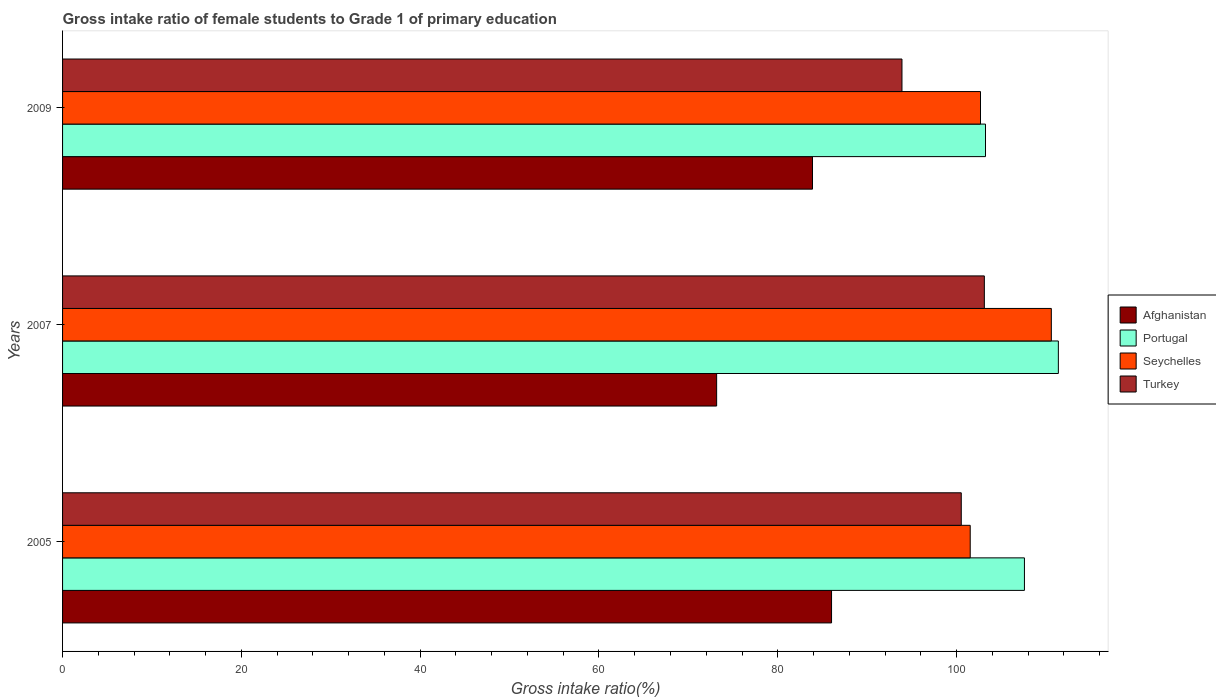Are the number of bars per tick equal to the number of legend labels?
Ensure brevity in your answer.  Yes. Are the number of bars on each tick of the Y-axis equal?
Your answer should be very brief. Yes. In how many cases, is the number of bars for a given year not equal to the number of legend labels?
Offer a very short reply. 0. What is the gross intake ratio in Afghanistan in 2009?
Your answer should be compact. 83.88. Across all years, what is the maximum gross intake ratio in Portugal?
Offer a terse response. 111.38. Across all years, what is the minimum gross intake ratio in Turkey?
Your response must be concise. 93.89. In which year was the gross intake ratio in Turkey maximum?
Keep it short and to the point. 2007. In which year was the gross intake ratio in Seychelles minimum?
Offer a terse response. 2005. What is the total gross intake ratio in Turkey in the graph?
Offer a very short reply. 297.52. What is the difference between the gross intake ratio in Turkey in 2007 and that in 2009?
Make the answer very short. 9.22. What is the difference between the gross intake ratio in Seychelles in 2009 and the gross intake ratio in Afghanistan in 2007?
Offer a terse response. 29.51. What is the average gross intake ratio in Seychelles per year?
Ensure brevity in your answer.  104.93. In the year 2007, what is the difference between the gross intake ratio in Portugal and gross intake ratio in Afghanistan?
Make the answer very short. 38.22. In how many years, is the gross intake ratio in Afghanistan greater than 80 %?
Provide a succinct answer. 2. What is the ratio of the gross intake ratio in Turkey in 2005 to that in 2007?
Provide a short and direct response. 0.97. Is the gross intake ratio in Portugal in 2005 less than that in 2009?
Keep it short and to the point. No. Is the difference between the gross intake ratio in Portugal in 2007 and 2009 greater than the difference between the gross intake ratio in Afghanistan in 2007 and 2009?
Offer a very short reply. Yes. What is the difference between the highest and the second highest gross intake ratio in Turkey?
Your answer should be compact. 2.58. What is the difference between the highest and the lowest gross intake ratio in Portugal?
Your response must be concise. 8.15. In how many years, is the gross intake ratio in Turkey greater than the average gross intake ratio in Turkey taken over all years?
Offer a terse response. 2. Is the sum of the gross intake ratio in Portugal in 2005 and 2009 greater than the maximum gross intake ratio in Seychelles across all years?
Keep it short and to the point. Yes. What does the 2nd bar from the top in 2009 represents?
Provide a short and direct response. Seychelles. What does the 2nd bar from the bottom in 2007 represents?
Your response must be concise. Portugal. Is it the case that in every year, the sum of the gross intake ratio in Afghanistan and gross intake ratio in Turkey is greater than the gross intake ratio in Seychelles?
Your answer should be compact. Yes. How many bars are there?
Offer a terse response. 12. What is the difference between two consecutive major ticks on the X-axis?
Provide a succinct answer. 20. Are the values on the major ticks of X-axis written in scientific E-notation?
Offer a terse response. No. Does the graph contain any zero values?
Provide a short and direct response. No. Does the graph contain grids?
Your answer should be compact. No. Where does the legend appear in the graph?
Make the answer very short. Center right. What is the title of the graph?
Give a very brief answer. Gross intake ratio of female students to Grade 1 of primary education. Does "Cayman Islands" appear as one of the legend labels in the graph?
Provide a short and direct response. No. What is the label or title of the X-axis?
Your response must be concise. Gross intake ratio(%). What is the label or title of the Y-axis?
Offer a terse response. Years. What is the Gross intake ratio(%) of Afghanistan in 2005?
Your response must be concise. 86.01. What is the Gross intake ratio(%) of Portugal in 2005?
Provide a short and direct response. 107.59. What is the Gross intake ratio(%) in Seychelles in 2005?
Ensure brevity in your answer.  101.52. What is the Gross intake ratio(%) in Turkey in 2005?
Provide a short and direct response. 100.52. What is the Gross intake ratio(%) in Afghanistan in 2007?
Your response must be concise. 73.16. What is the Gross intake ratio(%) in Portugal in 2007?
Your response must be concise. 111.38. What is the Gross intake ratio(%) in Seychelles in 2007?
Provide a succinct answer. 110.6. What is the Gross intake ratio(%) in Turkey in 2007?
Provide a short and direct response. 103.11. What is the Gross intake ratio(%) of Afghanistan in 2009?
Make the answer very short. 83.88. What is the Gross intake ratio(%) of Portugal in 2009?
Provide a succinct answer. 103.23. What is the Gross intake ratio(%) of Seychelles in 2009?
Your answer should be very brief. 102.67. What is the Gross intake ratio(%) in Turkey in 2009?
Your response must be concise. 93.89. Across all years, what is the maximum Gross intake ratio(%) in Afghanistan?
Keep it short and to the point. 86.01. Across all years, what is the maximum Gross intake ratio(%) of Portugal?
Provide a succinct answer. 111.38. Across all years, what is the maximum Gross intake ratio(%) in Seychelles?
Provide a succinct answer. 110.6. Across all years, what is the maximum Gross intake ratio(%) of Turkey?
Offer a terse response. 103.11. Across all years, what is the minimum Gross intake ratio(%) of Afghanistan?
Offer a terse response. 73.16. Across all years, what is the minimum Gross intake ratio(%) in Portugal?
Your answer should be very brief. 103.23. Across all years, what is the minimum Gross intake ratio(%) in Seychelles?
Your response must be concise. 101.52. Across all years, what is the minimum Gross intake ratio(%) of Turkey?
Offer a terse response. 93.89. What is the total Gross intake ratio(%) of Afghanistan in the graph?
Ensure brevity in your answer.  243.06. What is the total Gross intake ratio(%) of Portugal in the graph?
Your answer should be very brief. 322.21. What is the total Gross intake ratio(%) of Seychelles in the graph?
Provide a short and direct response. 314.8. What is the total Gross intake ratio(%) of Turkey in the graph?
Provide a succinct answer. 297.52. What is the difference between the Gross intake ratio(%) in Afghanistan in 2005 and that in 2007?
Your answer should be very brief. 12.85. What is the difference between the Gross intake ratio(%) of Portugal in 2005 and that in 2007?
Your answer should be very brief. -3.79. What is the difference between the Gross intake ratio(%) in Seychelles in 2005 and that in 2007?
Give a very brief answer. -9.07. What is the difference between the Gross intake ratio(%) in Turkey in 2005 and that in 2007?
Ensure brevity in your answer.  -2.58. What is the difference between the Gross intake ratio(%) in Afghanistan in 2005 and that in 2009?
Offer a terse response. 2.13. What is the difference between the Gross intake ratio(%) of Portugal in 2005 and that in 2009?
Make the answer very short. 4.36. What is the difference between the Gross intake ratio(%) of Seychelles in 2005 and that in 2009?
Give a very brief answer. -1.15. What is the difference between the Gross intake ratio(%) in Turkey in 2005 and that in 2009?
Provide a short and direct response. 6.63. What is the difference between the Gross intake ratio(%) of Afghanistan in 2007 and that in 2009?
Your answer should be compact. -10.72. What is the difference between the Gross intake ratio(%) of Portugal in 2007 and that in 2009?
Make the answer very short. 8.15. What is the difference between the Gross intake ratio(%) of Seychelles in 2007 and that in 2009?
Provide a succinct answer. 7.92. What is the difference between the Gross intake ratio(%) in Turkey in 2007 and that in 2009?
Your response must be concise. 9.22. What is the difference between the Gross intake ratio(%) in Afghanistan in 2005 and the Gross intake ratio(%) in Portugal in 2007?
Your response must be concise. -25.37. What is the difference between the Gross intake ratio(%) in Afghanistan in 2005 and the Gross intake ratio(%) in Seychelles in 2007?
Give a very brief answer. -24.58. What is the difference between the Gross intake ratio(%) in Afghanistan in 2005 and the Gross intake ratio(%) in Turkey in 2007?
Provide a short and direct response. -17.09. What is the difference between the Gross intake ratio(%) of Portugal in 2005 and the Gross intake ratio(%) of Seychelles in 2007?
Your response must be concise. -3.01. What is the difference between the Gross intake ratio(%) in Portugal in 2005 and the Gross intake ratio(%) in Turkey in 2007?
Your response must be concise. 4.48. What is the difference between the Gross intake ratio(%) of Seychelles in 2005 and the Gross intake ratio(%) of Turkey in 2007?
Your answer should be very brief. -1.58. What is the difference between the Gross intake ratio(%) of Afghanistan in 2005 and the Gross intake ratio(%) of Portugal in 2009?
Offer a very short reply. -17.22. What is the difference between the Gross intake ratio(%) of Afghanistan in 2005 and the Gross intake ratio(%) of Seychelles in 2009?
Provide a succinct answer. -16.66. What is the difference between the Gross intake ratio(%) of Afghanistan in 2005 and the Gross intake ratio(%) of Turkey in 2009?
Your answer should be very brief. -7.88. What is the difference between the Gross intake ratio(%) of Portugal in 2005 and the Gross intake ratio(%) of Seychelles in 2009?
Give a very brief answer. 4.91. What is the difference between the Gross intake ratio(%) in Portugal in 2005 and the Gross intake ratio(%) in Turkey in 2009?
Provide a succinct answer. 13.7. What is the difference between the Gross intake ratio(%) of Seychelles in 2005 and the Gross intake ratio(%) of Turkey in 2009?
Your answer should be compact. 7.63. What is the difference between the Gross intake ratio(%) of Afghanistan in 2007 and the Gross intake ratio(%) of Portugal in 2009?
Offer a very short reply. -30.07. What is the difference between the Gross intake ratio(%) of Afghanistan in 2007 and the Gross intake ratio(%) of Seychelles in 2009?
Your answer should be compact. -29.51. What is the difference between the Gross intake ratio(%) of Afghanistan in 2007 and the Gross intake ratio(%) of Turkey in 2009?
Provide a short and direct response. -20.73. What is the difference between the Gross intake ratio(%) of Portugal in 2007 and the Gross intake ratio(%) of Seychelles in 2009?
Offer a very short reply. 8.71. What is the difference between the Gross intake ratio(%) of Portugal in 2007 and the Gross intake ratio(%) of Turkey in 2009?
Your answer should be very brief. 17.49. What is the difference between the Gross intake ratio(%) of Seychelles in 2007 and the Gross intake ratio(%) of Turkey in 2009?
Your answer should be compact. 16.71. What is the average Gross intake ratio(%) in Afghanistan per year?
Keep it short and to the point. 81.02. What is the average Gross intake ratio(%) of Portugal per year?
Provide a succinct answer. 107.4. What is the average Gross intake ratio(%) in Seychelles per year?
Your answer should be compact. 104.93. What is the average Gross intake ratio(%) in Turkey per year?
Your answer should be compact. 99.17. In the year 2005, what is the difference between the Gross intake ratio(%) in Afghanistan and Gross intake ratio(%) in Portugal?
Provide a succinct answer. -21.58. In the year 2005, what is the difference between the Gross intake ratio(%) of Afghanistan and Gross intake ratio(%) of Seychelles?
Your answer should be compact. -15.51. In the year 2005, what is the difference between the Gross intake ratio(%) in Afghanistan and Gross intake ratio(%) in Turkey?
Your response must be concise. -14.51. In the year 2005, what is the difference between the Gross intake ratio(%) of Portugal and Gross intake ratio(%) of Seychelles?
Provide a succinct answer. 6.06. In the year 2005, what is the difference between the Gross intake ratio(%) in Portugal and Gross intake ratio(%) in Turkey?
Your answer should be very brief. 7.06. In the year 2007, what is the difference between the Gross intake ratio(%) of Afghanistan and Gross intake ratio(%) of Portugal?
Give a very brief answer. -38.22. In the year 2007, what is the difference between the Gross intake ratio(%) of Afghanistan and Gross intake ratio(%) of Seychelles?
Keep it short and to the point. -37.44. In the year 2007, what is the difference between the Gross intake ratio(%) in Afghanistan and Gross intake ratio(%) in Turkey?
Your answer should be very brief. -29.94. In the year 2007, what is the difference between the Gross intake ratio(%) of Portugal and Gross intake ratio(%) of Seychelles?
Keep it short and to the point. 0.79. In the year 2007, what is the difference between the Gross intake ratio(%) in Portugal and Gross intake ratio(%) in Turkey?
Your answer should be compact. 8.28. In the year 2007, what is the difference between the Gross intake ratio(%) in Seychelles and Gross intake ratio(%) in Turkey?
Provide a succinct answer. 7.49. In the year 2009, what is the difference between the Gross intake ratio(%) of Afghanistan and Gross intake ratio(%) of Portugal?
Give a very brief answer. -19.35. In the year 2009, what is the difference between the Gross intake ratio(%) in Afghanistan and Gross intake ratio(%) in Seychelles?
Ensure brevity in your answer.  -18.79. In the year 2009, what is the difference between the Gross intake ratio(%) of Afghanistan and Gross intake ratio(%) of Turkey?
Keep it short and to the point. -10.01. In the year 2009, what is the difference between the Gross intake ratio(%) in Portugal and Gross intake ratio(%) in Seychelles?
Provide a succinct answer. 0.56. In the year 2009, what is the difference between the Gross intake ratio(%) of Portugal and Gross intake ratio(%) of Turkey?
Your answer should be very brief. 9.34. In the year 2009, what is the difference between the Gross intake ratio(%) in Seychelles and Gross intake ratio(%) in Turkey?
Your answer should be very brief. 8.78. What is the ratio of the Gross intake ratio(%) in Afghanistan in 2005 to that in 2007?
Ensure brevity in your answer.  1.18. What is the ratio of the Gross intake ratio(%) in Portugal in 2005 to that in 2007?
Make the answer very short. 0.97. What is the ratio of the Gross intake ratio(%) of Seychelles in 2005 to that in 2007?
Give a very brief answer. 0.92. What is the ratio of the Gross intake ratio(%) in Afghanistan in 2005 to that in 2009?
Provide a short and direct response. 1.03. What is the ratio of the Gross intake ratio(%) of Portugal in 2005 to that in 2009?
Offer a terse response. 1.04. What is the ratio of the Gross intake ratio(%) of Seychelles in 2005 to that in 2009?
Your answer should be compact. 0.99. What is the ratio of the Gross intake ratio(%) of Turkey in 2005 to that in 2009?
Provide a succinct answer. 1.07. What is the ratio of the Gross intake ratio(%) in Afghanistan in 2007 to that in 2009?
Your response must be concise. 0.87. What is the ratio of the Gross intake ratio(%) of Portugal in 2007 to that in 2009?
Keep it short and to the point. 1.08. What is the ratio of the Gross intake ratio(%) in Seychelles in 2007 to that in 2009?
Offer a very short reply. 1.08. What is the ratio of the Gross intake ratio(%) in Turkey in 2007 to that in 2009?
Provide a short and direct response. 1.1. What is the difference between the highest and the second highest Gross intake ratio(%) in Afghanistan?
Keep it short and to the point. 2.13. What is the difference between the highest and the second highest Gross intake ratio(%) of Portugal?
Offer a very short reply. 3.79. What is the difference between the highest and the second highest Gross intake ratio(%) in Seychelles?
Your answer should be compact. 7.92. What is the difference between the highest and the second highest Gross intake ratio(%) in Turkey?
Keep it short and to the point. 2.58. What is the difference between the highest and the lowest Gross intake ratio(%) of Afghanistan?
Offer a very short reply. 12.85. What is the difference between the highest and the lowest Gross intake ratio(%) in Portugal?
Ensure brevity in your answer.  8.15. What is the difference between the highest and the lowest Gross intake ratio(%) in Seychelles?
Your answer should be very brief. 9.07. What is the difference between the highest and the lowest Gross intake ratio(%) in Turkey?
Ensure brevity in your answer.  9.22. 